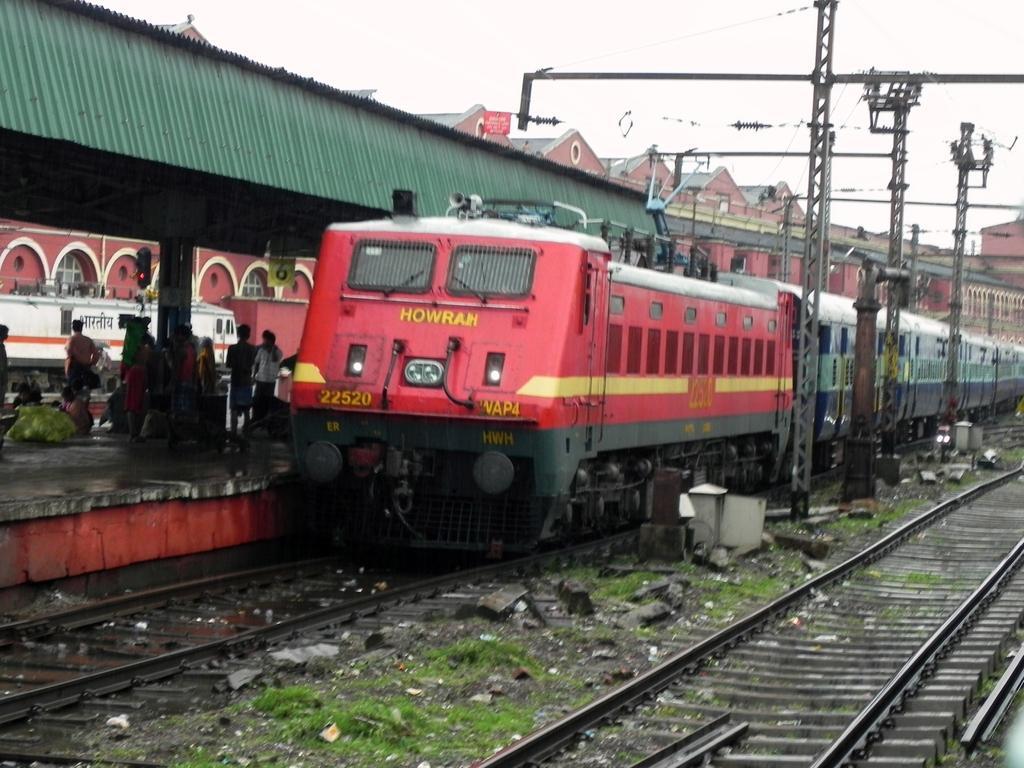Please provide a concise description of this image. In the foreground of this image, there are railway tracks and a train on it. We can also see few poles and people under the shed. In the background, there are buildings and the sky. 